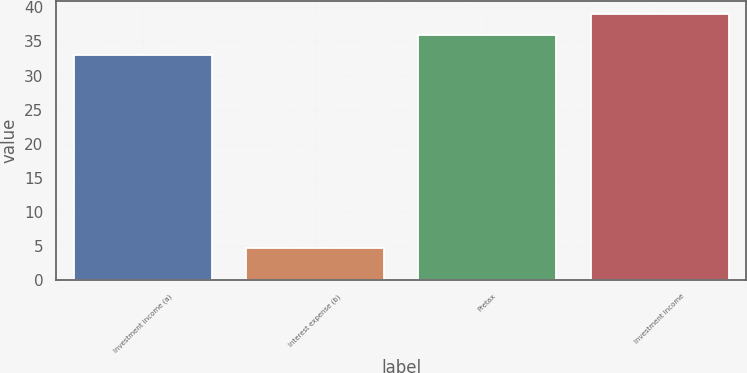Convert chart. <chart><loc_0><loc_0><loc_500><loc_500><bar_chart><fcel>Investment income (a)<fcel>Interest expense (b)<fcel>Pretax<fcel>Investment income<nl><fcel>33<fcel>4.75<fcel>36.02<fcel>39.05<nl></chart> 